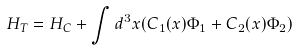<formula> <loc_0><loc_0><loc_500><loc_500>H _ { T } = H _ { C } + \int d ^ { 3 } x ( C _ { 1 } ( x ) \Phi _ { 1 } + C _ { 2 } ( x ) \Phi _ { 2 } )</formula> 